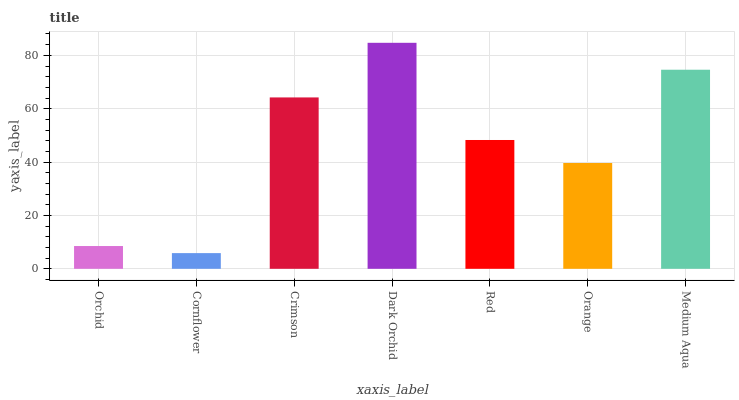Is Crimson the minimum?
Answer yes or no. No. Is Crimson the maximum?
Answer yes or no. No. Is Crimson greater than Cornflower?
Answer yes or no. Yes. Is Cornflower less than Crimson?
Answer yes or no. Yes. Is Cornflower greater than Crimson?
Answer yes or no. No. Is Crimson less than Cornflower?
Answer yes or no. No. Is Red the high median?
Answer yes or no. Yes. Is Red the low median?
Answer yes or no. Yes. Is Cornflower the high median?
Answer yes or no. No. Is Dark Orchid the low median?
Answer yes or no. No. 